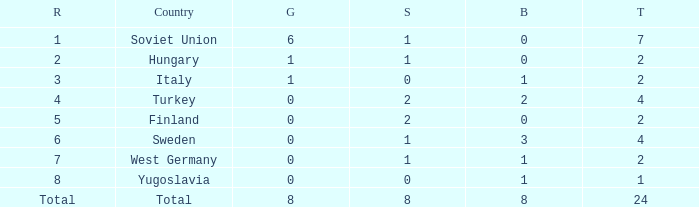What is the highest Total, when Gold is 1, when Nation is Hungary, and when Bronze is less than 0? None. 